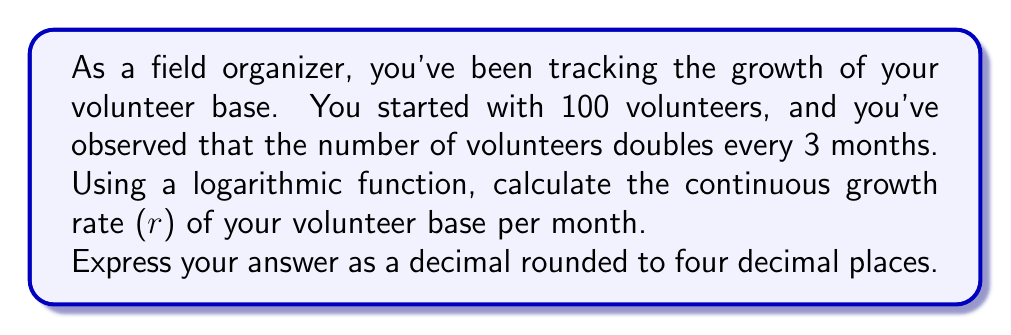Can you solve this math problem? To solve this problem, we'll use the continuous growth formula:

$$A = A_0 e^{rt}$$

Where:
$A$ is the final amount
$A_0$ is the initial amount
$e$ is Euler's number
$r$ is the continuous growth rate
$t$ is the time period

We know that:
$A_0 = 100$ (initial number of volunteers)
$A = 200$ (double the initial number)
$t = 3$ (months)

Let's substitute these values into the equation:

$$200 = 100 e^{3r}$$

Now, let's solve for $r$:

1) Divide both sides by 100:
   $$2 = e^{3r}$$

2) Take the natural log of both sides:
   $$\ln(2) = \ln(e^{3r})$$

3) Simplify the right side using the logarithm property $\ln(e^x) = x$:
   $$\ln(2) = 3r$$

4) Solve for $r$:
   $$r = \frac{\ln(2)}{3}$$

5) Calculate the value:
   $$r \approx 0.2310$$

This is the continuous growth rate per month.
Answer: 0.2310 